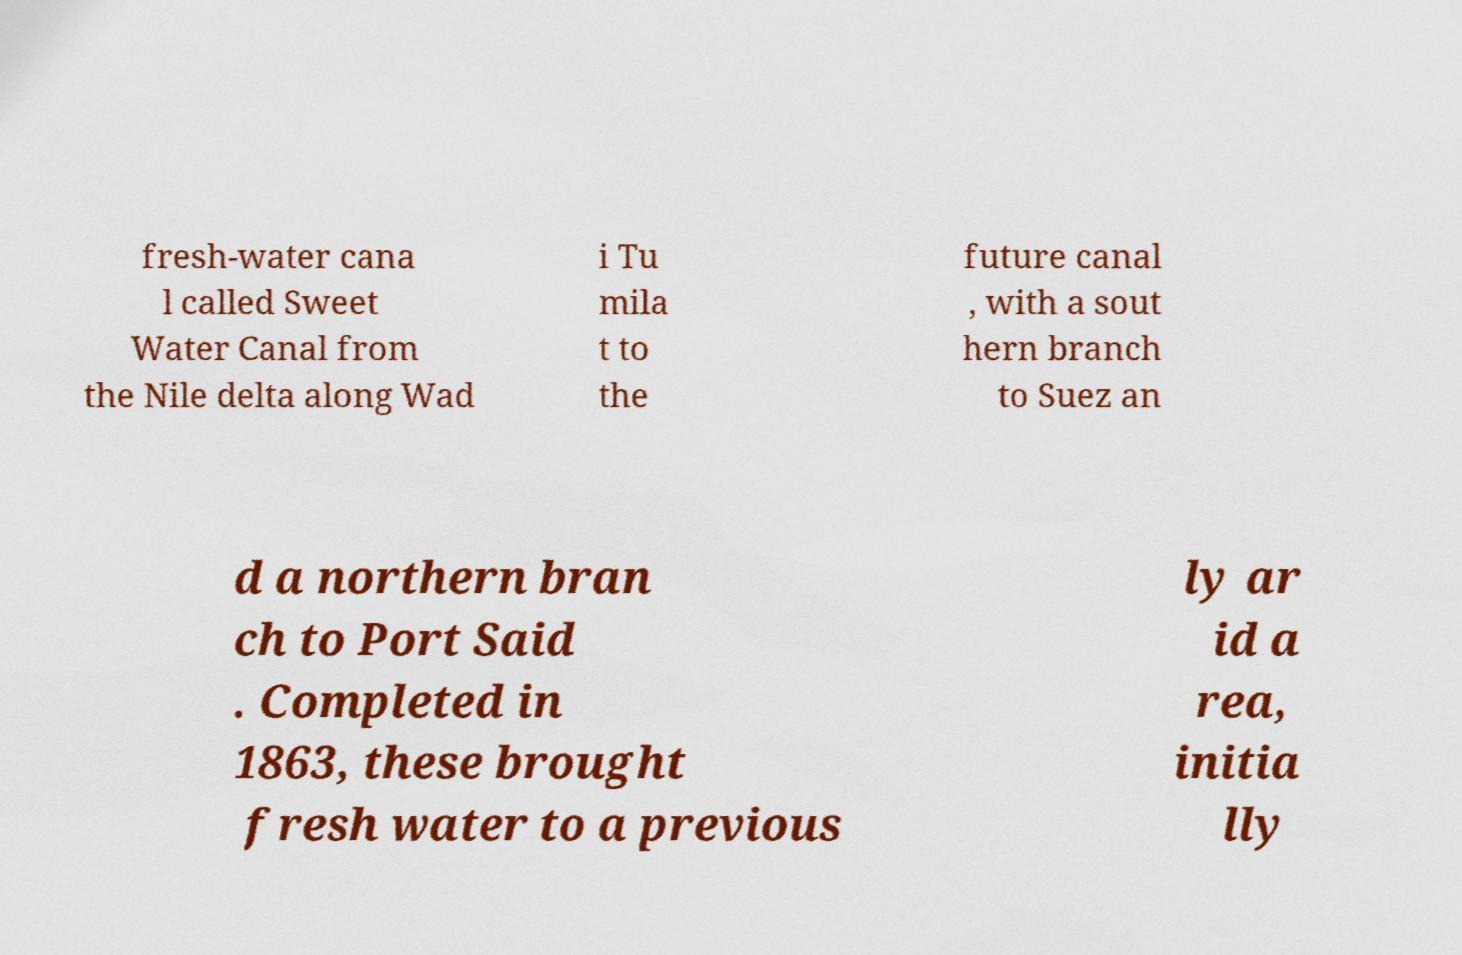Please identify and transcribe the text found in this image. fresh-water cana l called Sweet Water Canal from the Nile delta along Wad i Tu mila t to the future canal , with a sout hern branch to Suez an d a northern bran ch to Port Said . Completed in 1863, these brought fresh water to a previous ly ar id a rea, initia lly 